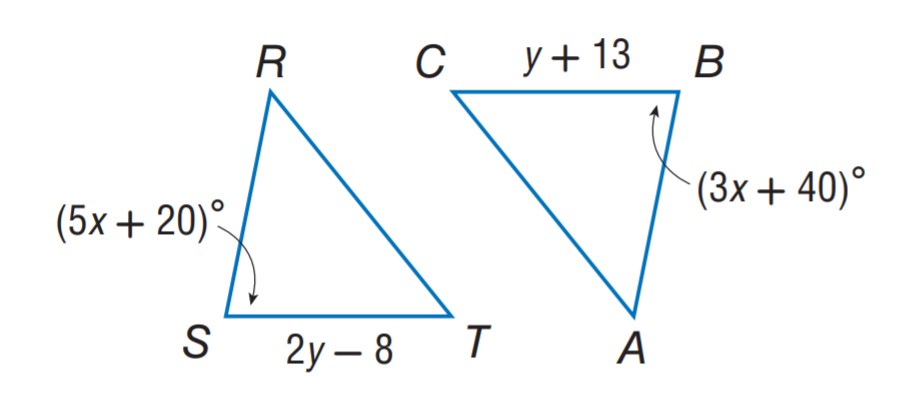Question: \triangle R S T \cong \triangle A B C. Find y.
Choices:
A. 13
B. 21
C. 31
D. 40
Answer with the letter. Answer: B 